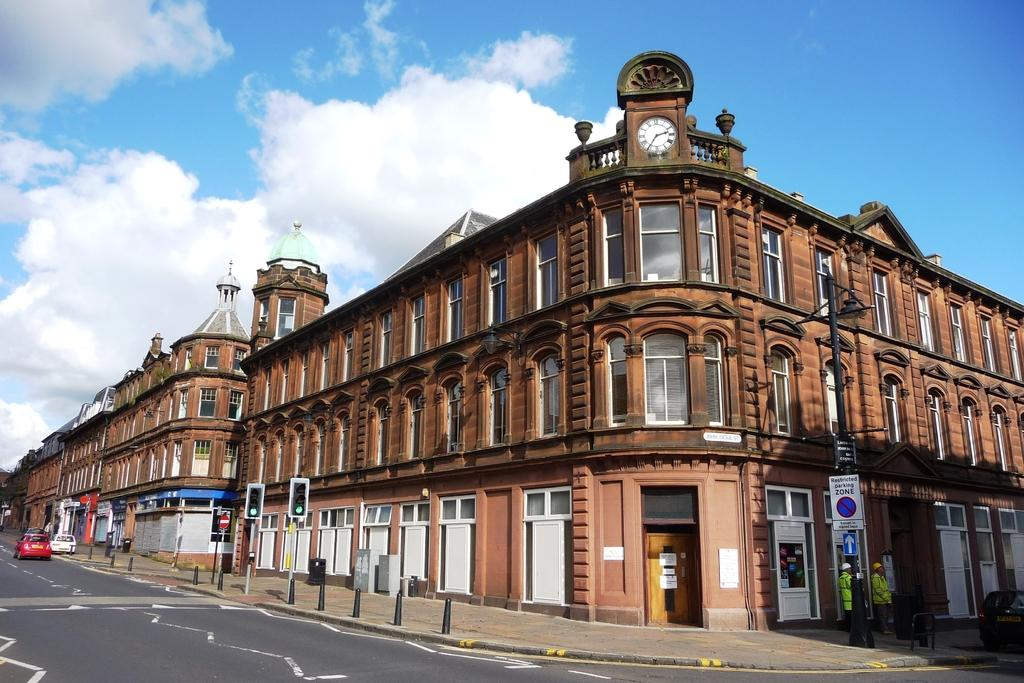What is the main focus of the image? The main focus of the image is the buildings in the center. Can you describe any other structures or objects in the image? Yes, there is a wall, a wall clock, windows, a door, poles, traffic lights, sign boards, a road, and a dust bin. Are there any people present in the image? Yes, two persons are standing in the image. What might be the purpose of the traffic lights in the image? The traffic lights are likely present to regulate the flow of vehicles on the road. How many vehicles are visible in the image? Few vehicles are visible in the image. How many boys are playing with the pigs in the image? There are no boys or pigs present in the image. The image focuses on buildings, structures, and objects in an urban setting. 